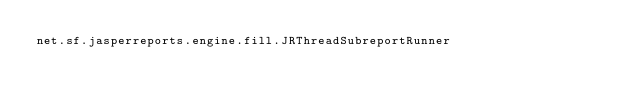<code> <loc_0><loc_0><loc_500><loc_500><_Rust_>net.sf.jasperreports.engine.fill.JRThreadSubreportRunner
</code> 